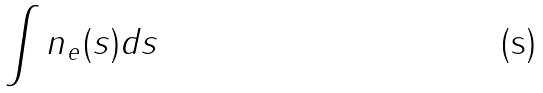<formula> <loc_0><loc_0><loc_500><loc_500>\int n _ { e } ( s ) d s</formula> 